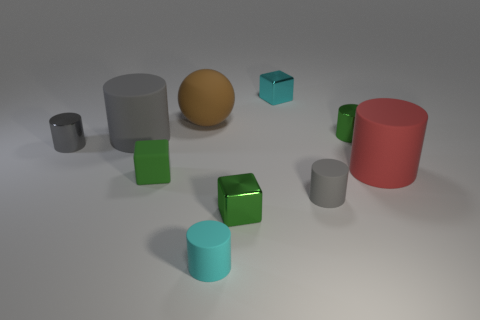How many big objects are either purple matte cubes or brown balls?
Provide a succinct answer. 1. How many other things are the same color as the matte cube?
Offer a very short reply. 2. How many small green shiny cylinders are to the right of the gray cylinder right of the tiny green shiny thing in front of the red matte cylinder?
Make the answer very short. 1. Do the shiny object to the left of the brown matte object and the green rubber object have the same size?
Provide a short and direct response. Yes. Are there fewer big matte objects in front of the cyan metallic thing than green matte objects right of the small cyan cylinder?
Your response must be concise. No. Does the big ball have the same color as the tiny matte cube?
Offer a terse response. No. Are there fewer matte cubes right of the large brown sphere than green metal objects?
Offer a very short reply. Yes. There is another block that is the same color as the rubber cube; what is its material?
Offer a terse response. Metal. Do the green cylinder and the big gray cylinder have the same material?
Provide a short and direct response. No. What number of large red cylinders are the same material as the ball?
Your response must be concise. 1. 